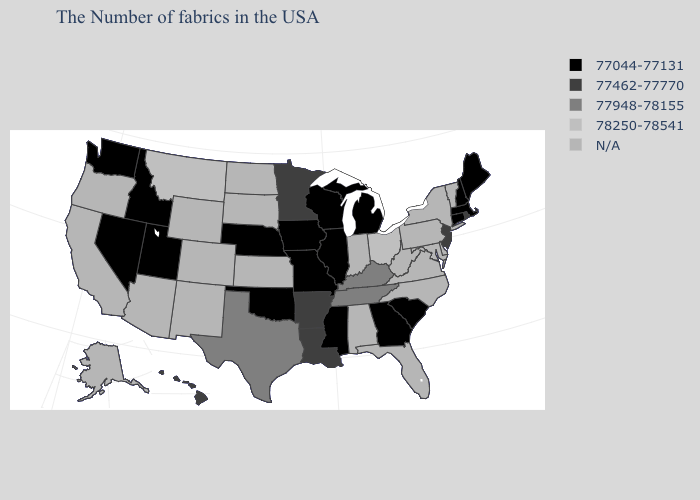Which states hav the highest value in the MidWest?
Concise answer only. Ohio. Name the states that have a value in the range N/A?
Answer briefly. Vermont, New York, Delaware, Maryland, Pennsylvania, Virginia, North Carolina, West Virginia, Florida, Indiana, Alabama, Kansas, South Dakota, North Dakota, Wyoming, Colorado, New Mexico, Arizona, California, Oregon, Alaska. Among the states that border West Virginia , does Kentucky have the highest value?
Short answer required. No. What is the value of Idaho?
Keep it brief. 77044-77131. What is the value of New Hampshire?
Answer briefly. 77044-77131. Does the map have missing data?
Quick response, please. Yes. Name the states that have a value in the range 77044-77131?
Give a very brief answer. Maine, Massachusetts, New Hampshire, Connecticut, South Carolina, Georgia, Michigan, Wisconsin, Illinois, Mississippi, Missouri, Iowa, Nebraska, Oklahoma, Utah, Idaho, Nevada, Washington. Name the states that have a value in the range N/A?
Short answer required. Vermont, New York, Delaware, Maryland, Pennsylvania, Virginia, North Carolina, West Virginia, Florida, Indiana, Alabama, Kansas, South Dakota, North Dakota, Wyoming, Colorado, New Mexico, Arizona, California, Oregon, Alaska. Does New Jersey have the lowest value in the USA?
Keep it brief. No. What is the highest value in states that border Kansas?
Answer briefly. 77044-77131. What is the value of South Dakota?
Answer briefly. N/A. Name the states that have a value in the range 77462-77770?
Quick response, please. Rhode Island, New Jersey, Louisiana, Arkansas, Minnesota, Hawaii. What is the lowest value in the USA?
Short answer required. 77044-77131. 